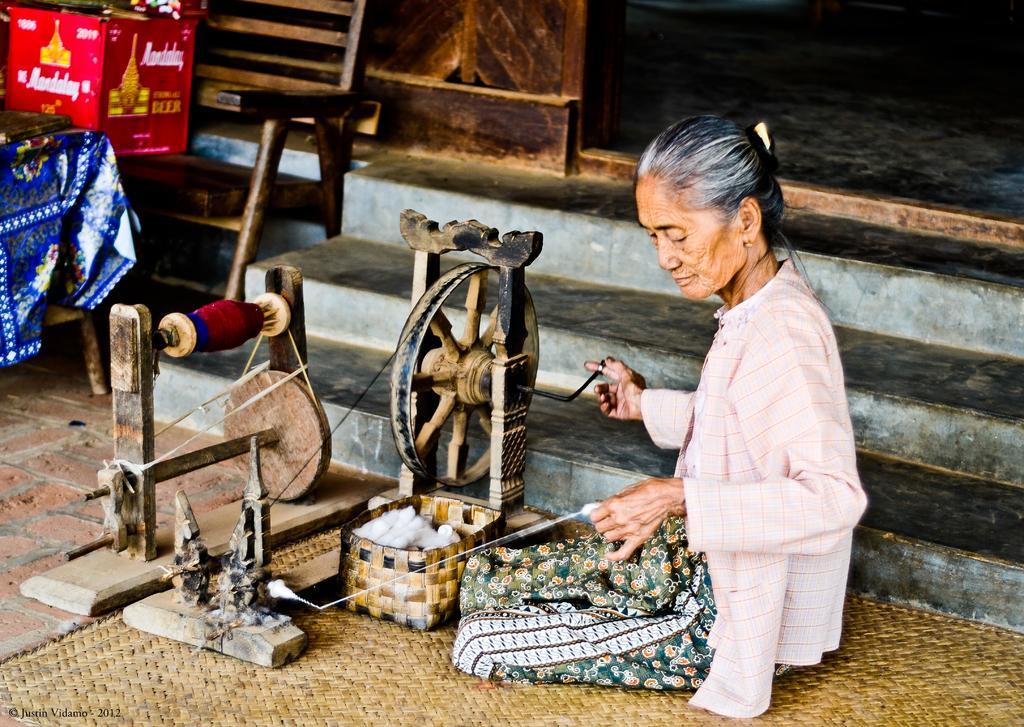How would you summarize this image in a sentence or two? This image is taken outdoors. At the bottom of the image there is a mat on the floor. On the left side of the image there is a table with a tablecloth on it and there is a cardboard box on the chair. In the background there are a few steps and there is a wall. In the middle of the image a woman is sitting on the mat and she is spinning the wheel to make a thread with cotton and there is a cotton in the basket. 